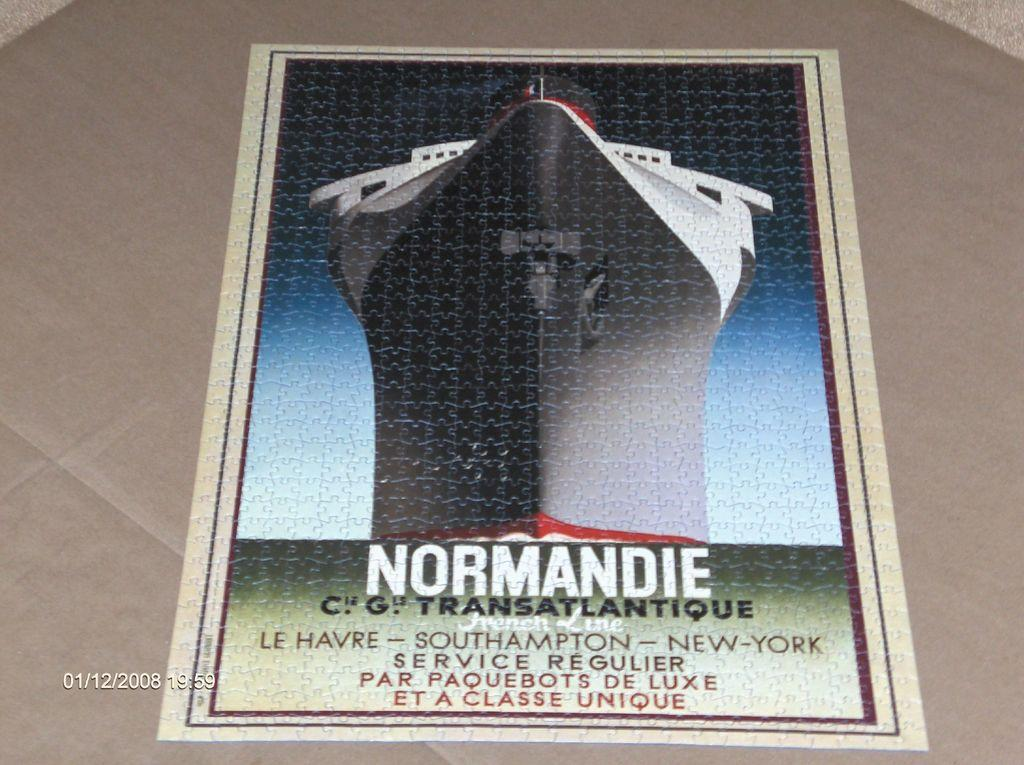<image>
Describe the image concisely. Poster that shows a giant ship and the word "Normandie" below it. 